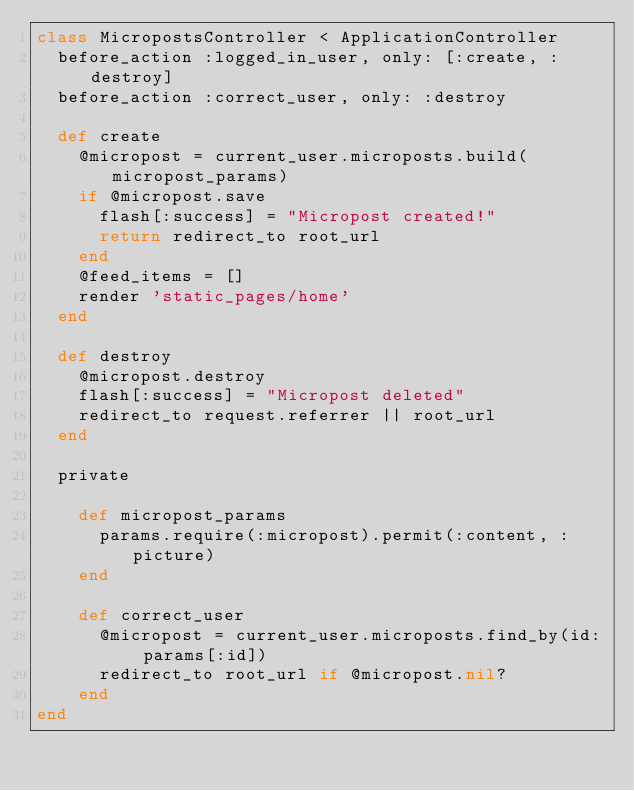<code> <loc_0><loc_0><loc_500><loc_500><_Ruby_>class MicropostsController < ApplicationController
  before_action :logged_in_user, only: [:create, :destroy]
  before_action :correct_user, only: :destroy

  def create
    @micropost = current_user.microposts.build(micropost_params)
    if @micropost.save
      flash[:success] = "Micropost created!"
      return redirect_to root_url
    end
    @feed_items = []
    render 'static_pages/home'
  end

  def destroy
    @micropost.destroy
    flash[:success] = "Micropost deleted"
    redirect_to request.referrer || root_url
  end

  private

    def micropost_params
      params.require(:micropost).permit(:content, :picture)
    end

    def correct_user
      @micropost = current_user.microposts.find_by(id: params[:id])
      redirect_to root_url if @micropost.nil?
    end
end</code> 